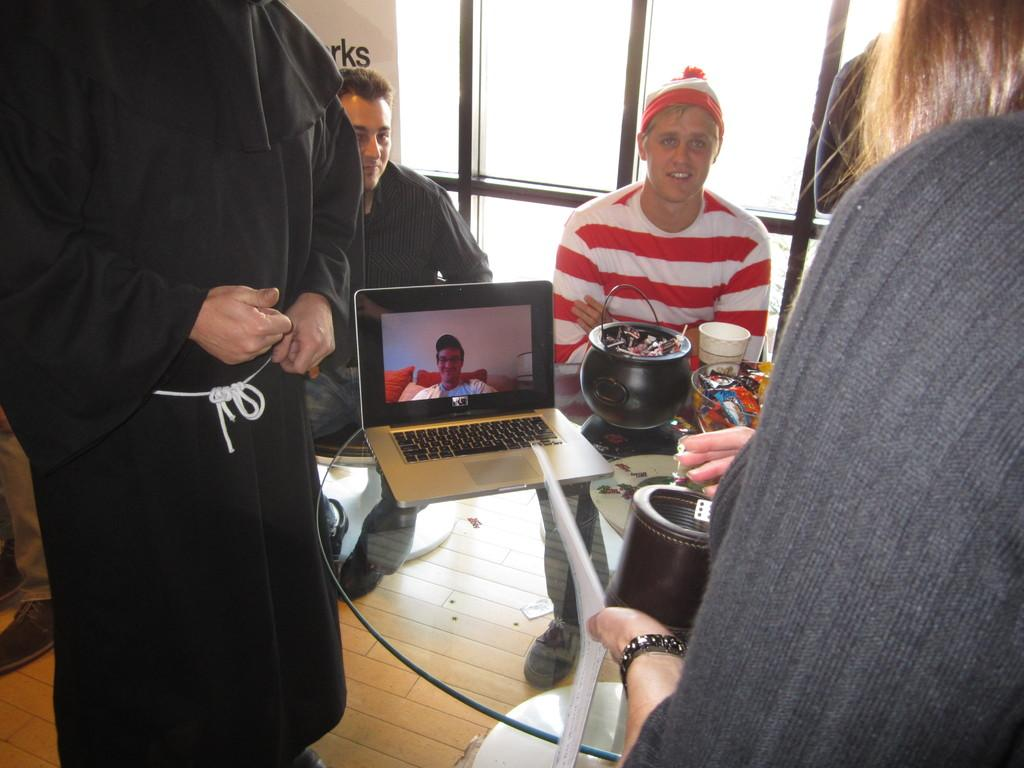How many persons are in the image? There are persons in the image. What are the positions of two of the persons in the image? Two of the persons are sitting on chairs. What is the main piece of furniture in the image? There is a table in the image. What electronic device is on the table? A laptop is present on the table. What type of dishware is on the table? There are bowls on the table. What type of beverage container is on the table? There is a cup on the table. What can be seen in the background of the image? There are glasses visible in the background. What type of camera is being used by the friend in the image? There is no friend or camera present in the image. What act are the persons in the image performing? The image does not depict any specific act or activity being performed by the persons. 